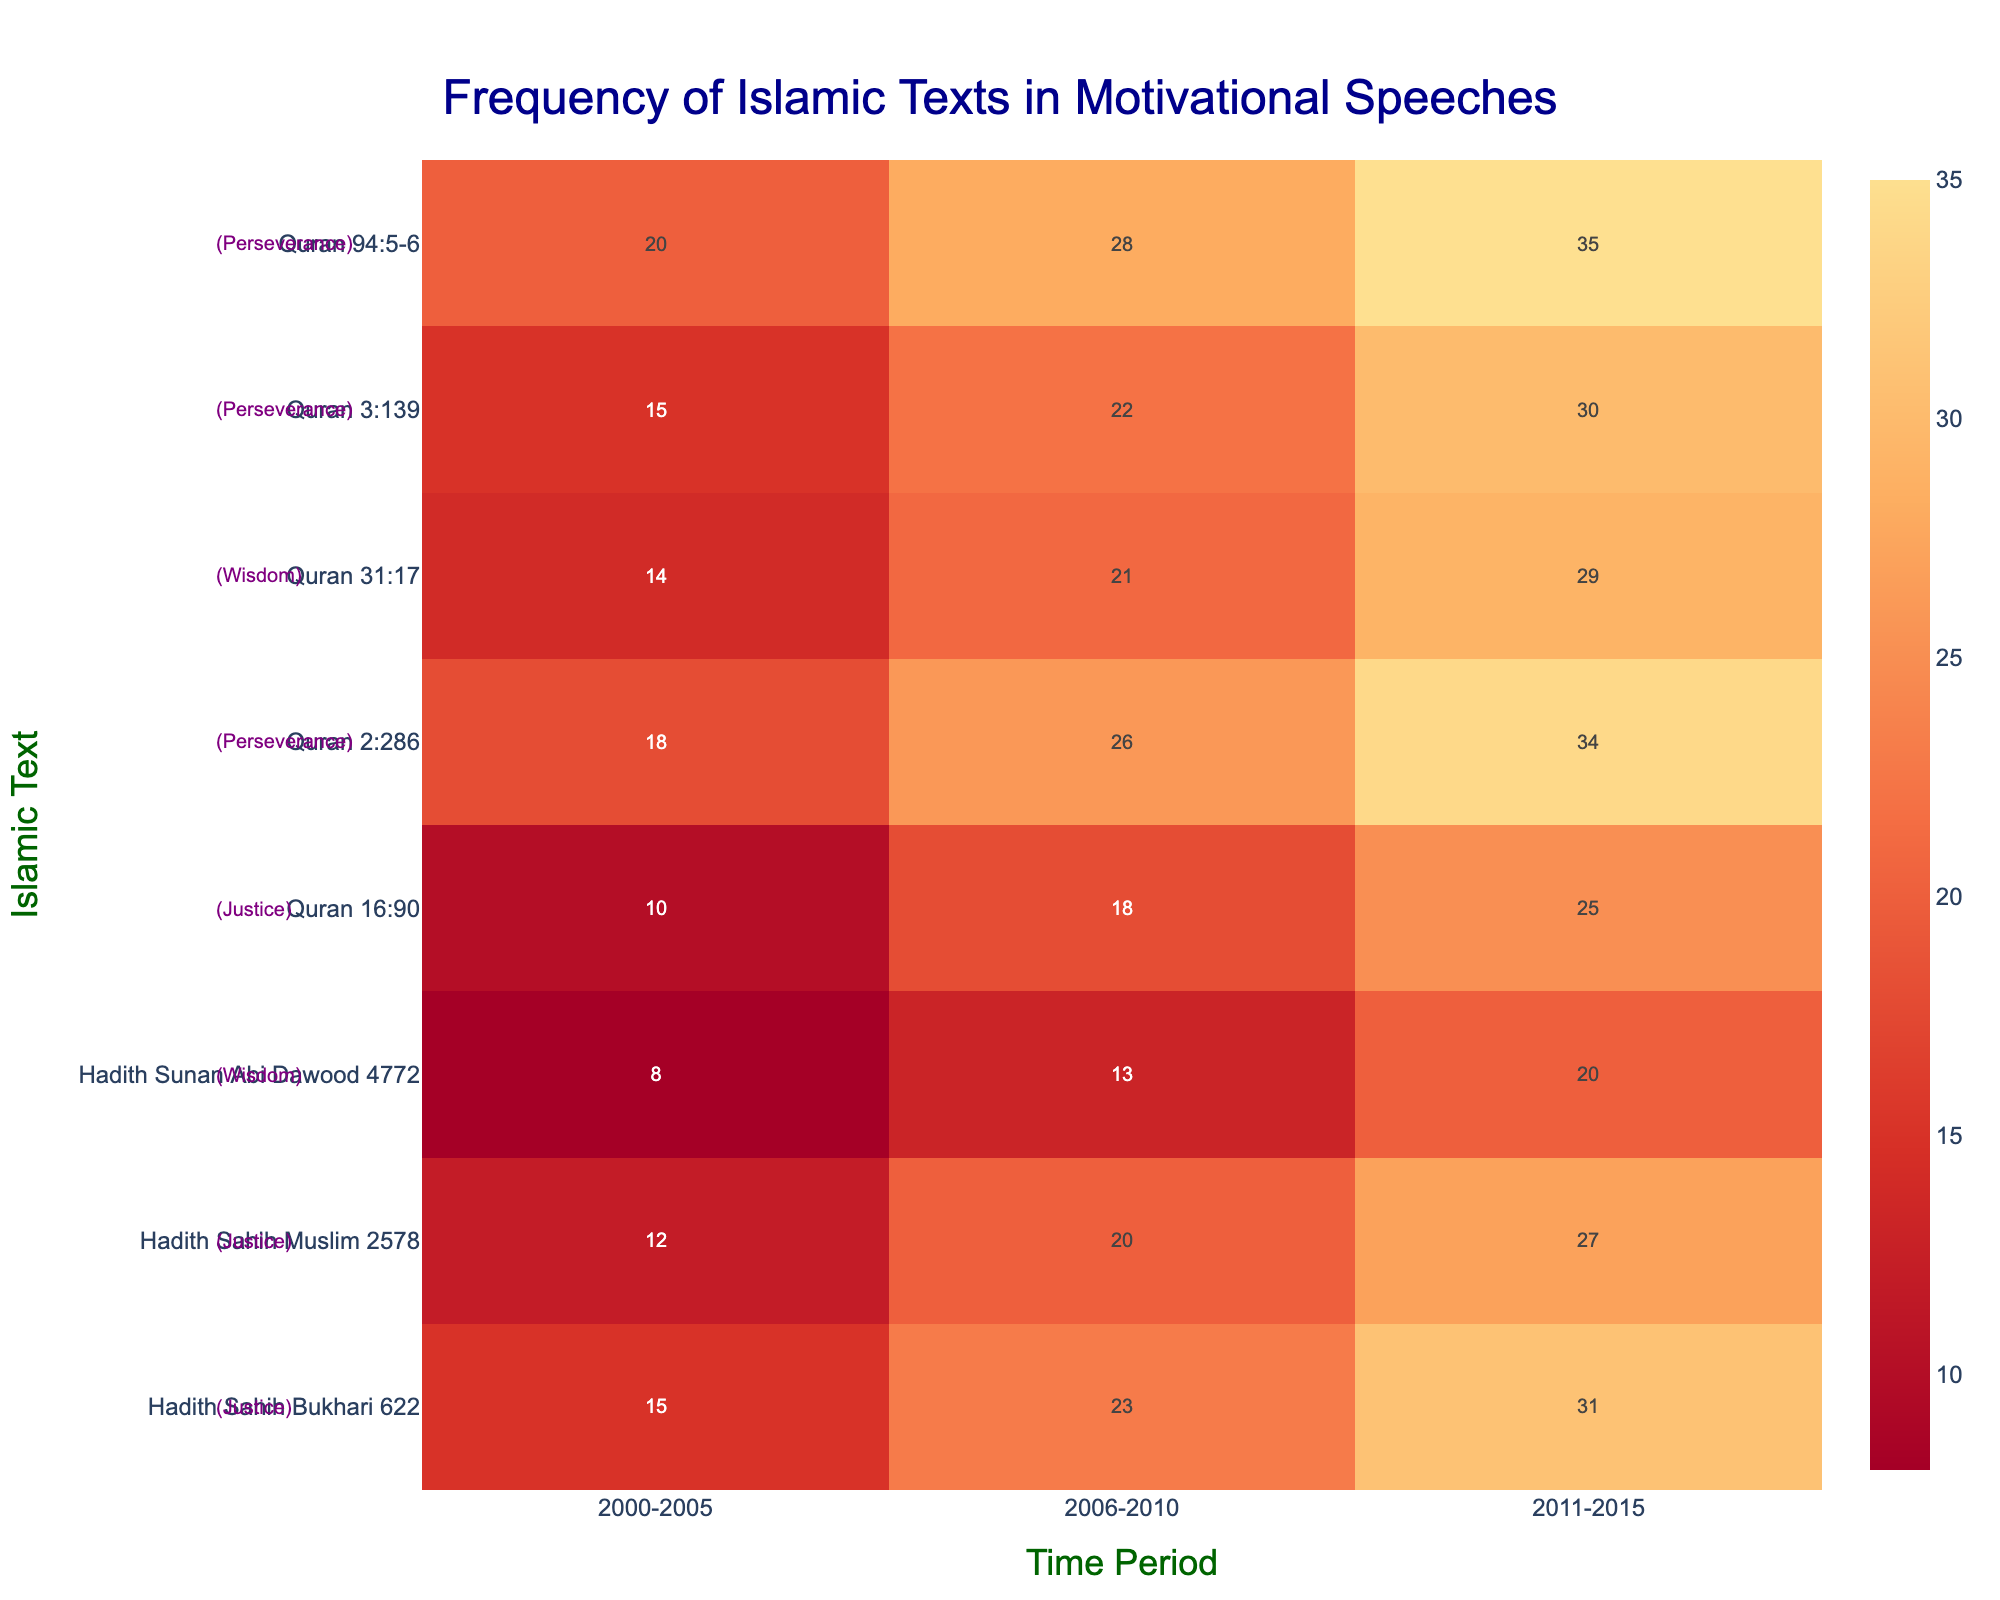What is the title of the heatmap? The title is usually placed at the top of the heatmap and describes the main focus of the analysis. The title acts as an entry point to understand the subject of the plot.
Answer: Frequency of Islamic Texts in Motivational Speeches Which time period shows the highest frequency for "Quran 3:139"? Look for the row corresponding to "Quran 3:139" and identify the highest value across the different time periods.
Answer: 2011-2015 How many unique Islamic texts are analyzed in the plot? Count the total number of rows in the heatmap which represent the unique texts.
Answer: 9 Which theme is annotated beside "Hadith Sunan Abi Dawood 4772"? Check the annotation added beside the text name on the left side of the plot.
Answer: Wisdom Between 2000-2005 and 2011-2015, is there a greater increase in frequency for "Quran 94:5-6" or "Hadith Sahih Bukhari 622"? Calculate the frequency difference for both texts between these time periods. "Quran 94:5-6" (35 - 20 = 15), "Hadith Sahih Bukhari 622" (31 - 15 = 16). Compare the results.
Answer: Hadith Sahih Bukhari 622 Which text related to the theme of justice shows the most consistent increase in frequency across the time periods? Identify texts themed as 'justice' and observe the pattern of frequency increase through the time periods.
Answer: Hadith Sahih Muslim 2578 What is the overall trend in the usage of "Quran 2:286" over the specified periods? Check the frequency values across each time period for "Quran 2:286" and note the trend.
Answer: Increasing How does the frequency of "Hadith Sunan Abi Dawood 4772" in 2006-2010 compare to its frequency in 2000-2005? Compare the frequency values of "Hadith Sunan Abi Dawood 4772" between the two periods: 13 in 2006-2010 and 8 in 2000-2005.
Answer: Higher Which text has the highest frequency value in the 2011-2015 period? Scan through the column corresponding to the 2011-2015 period and find the highest value.
Answer: Quran 94:5-6 How does the frequency of texts categorized under 'Perseverance' change from 2000-2015? Aggregate the frequencies of texts under 'Perseverance' for each time period and observe the trend.
Answer: It increases continuously 